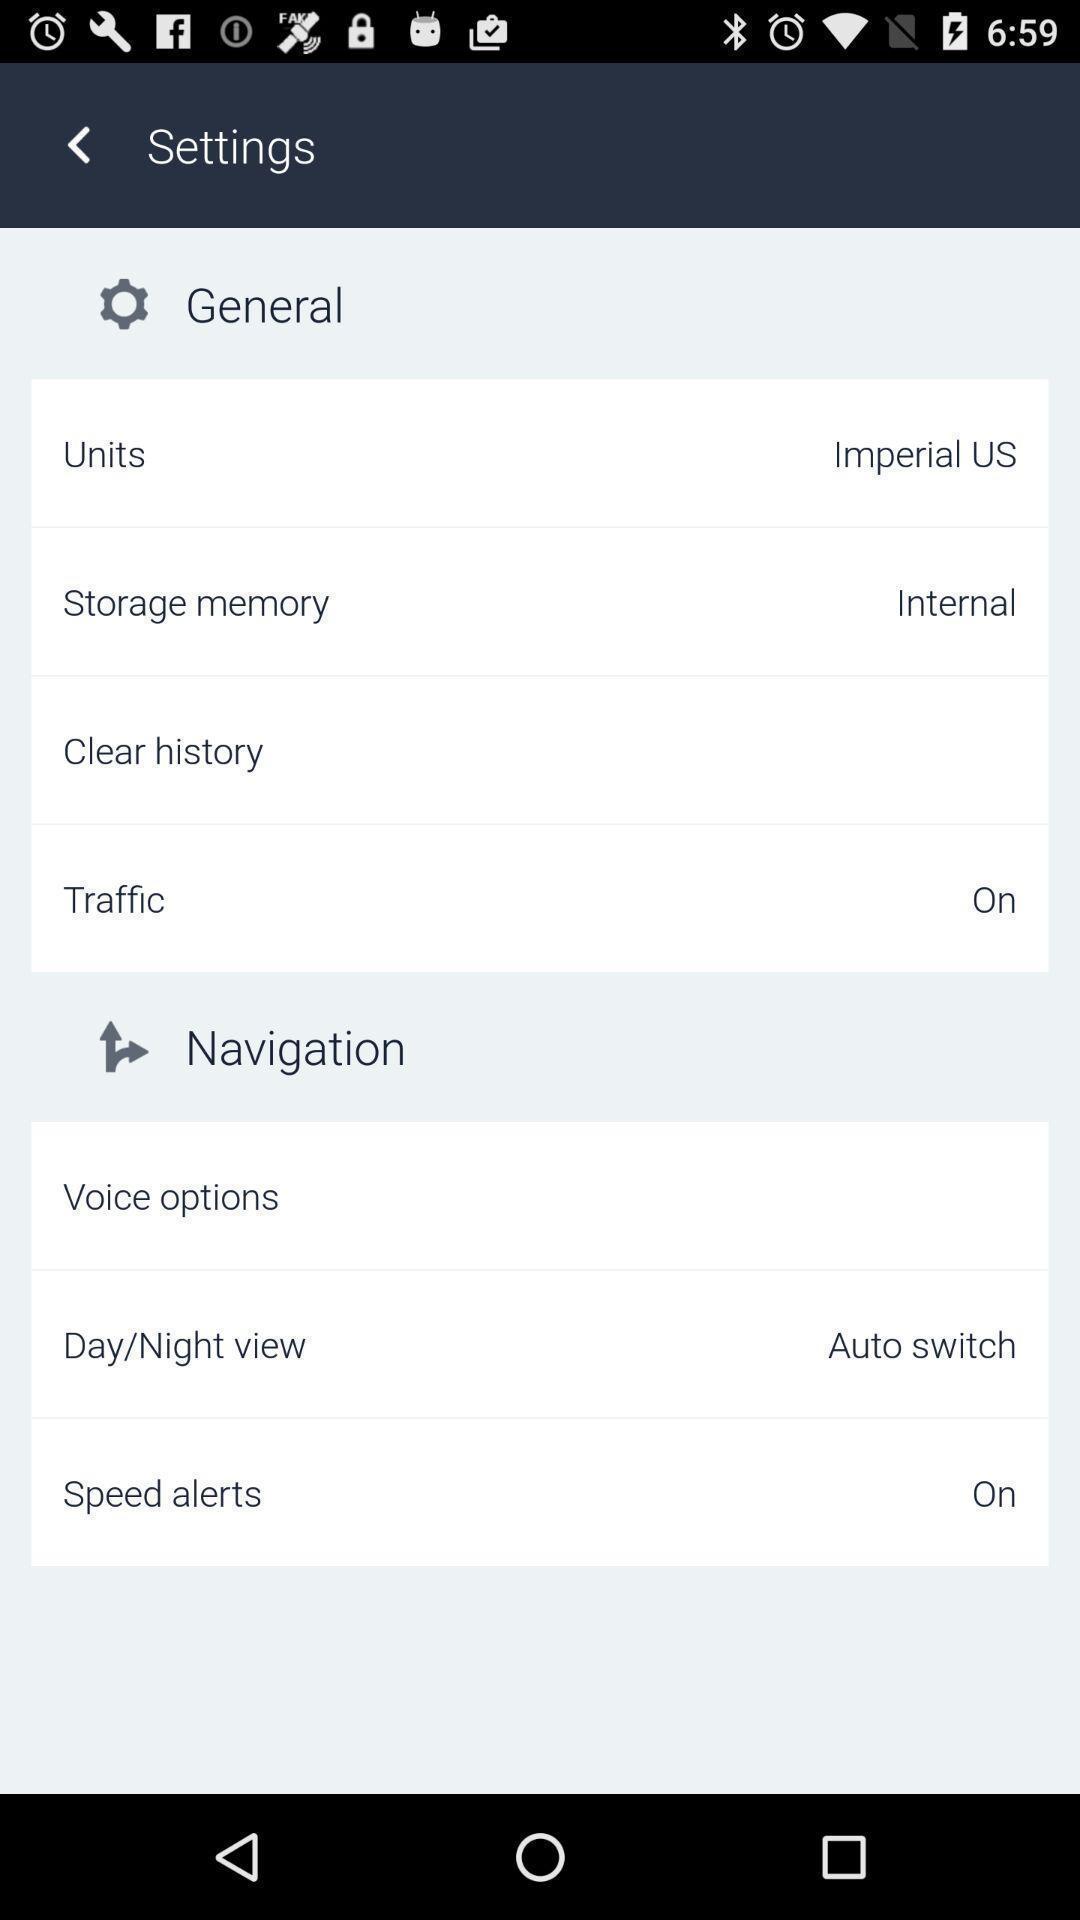Summarize the main components in this picture. Screen showing settings page. 